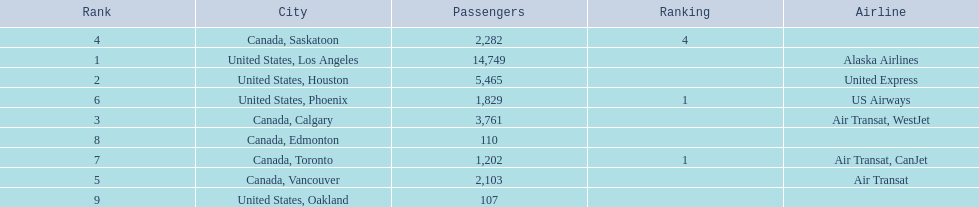What are the cities that are associated with the playa de oro international airport? United States, Los Angeles, United States, Houston, Canada, Calgary, Canada, Saskatoon, Canada, Vancouver, United States, Phoenix, Canada, Toronto, Canada, Edmonton, United States, Oakland. What is uniteed states, los angeles passenger count? 14,749. What other cities passenger count would lead to 19,000 roughly when combined with previous los angeles? Canada, Calgary. 